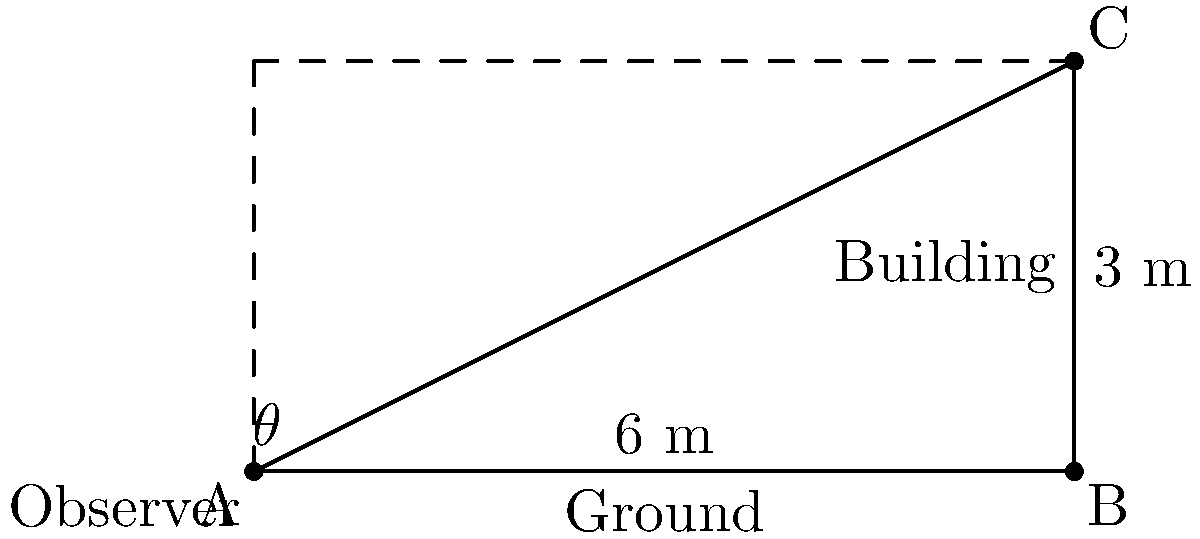As a psychology professor specializing in negotiation theory, you often use visual aids to illustrate concepts. In a discussion about perspective-taking, you present the following scenario:

An observer stands on the ground and looks up at the top of a building. The distance from the observer to the base of the building is 6 meters, and the height of the building is 3 meters. What is the angle of elevation (θ) from the observer's eye level to the top of the building? Round your answer to the nearest degree. To solve this problem, we'll use trigonometry, specifically the tangent function. Let's break it down step-by-step:

1) In a right triangle, tangent of an angle is the ratio of the opposite side to the adjacent side.

2) In this case:
   - The opposite side is the height of the building (3 meters)
   - The adjacent side is the distance from the observer to the building (6 meters)

3) We can express this as:

   $$\tan(\theta) = \frac{\text{opposite}}{\text{adjacent}} = \frac{3}{6} = \frac{1}{2}$$

4) To find θ, we need to use the inverse tangent (arctan or $\tan^{-1}$) function:

   $$\theta = \tan^{-1}(\frac{1}{2})$$

5) Using a calculator or trigonometric tables:

   $$\theta \approx 26.57°$$

6) Rounding to the nearest degree:

   $$\theta \approx 27°$$

This angle represents the observer's perspective when looking at the top of the building, which could be used as a metaphor for understanding different viewpoints in negotiations.
Answer: $27°$ 